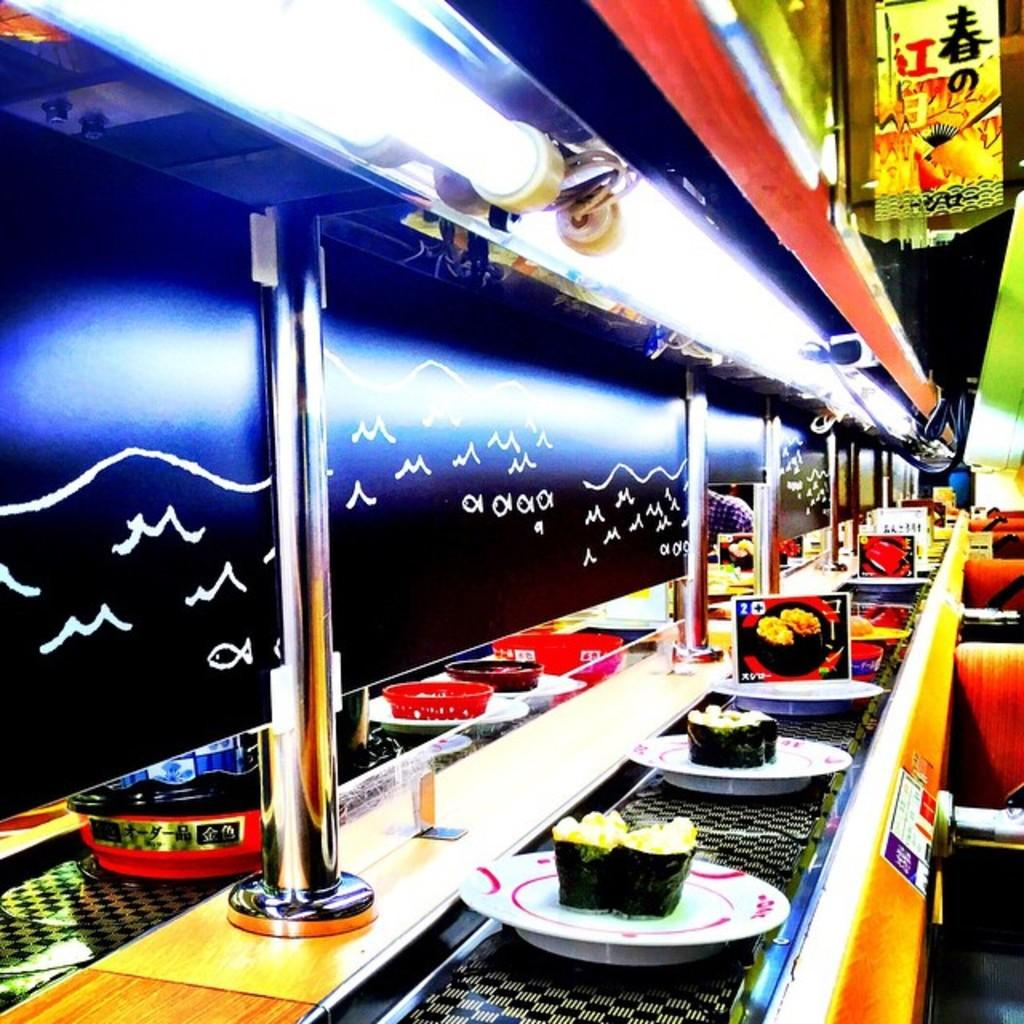What is on the serving plates in the image? There are serving plates with food in the image. What else can be seen in the image besides the serving plates? Advertisement boards and electric lights are visible in the image. What type of surface is visible beneath the serving plates and other objects? The floor is visible in the image. What type of fiction is being read by the person in the image? There is no person present in the image, and therefore no one is reading any fiction. 